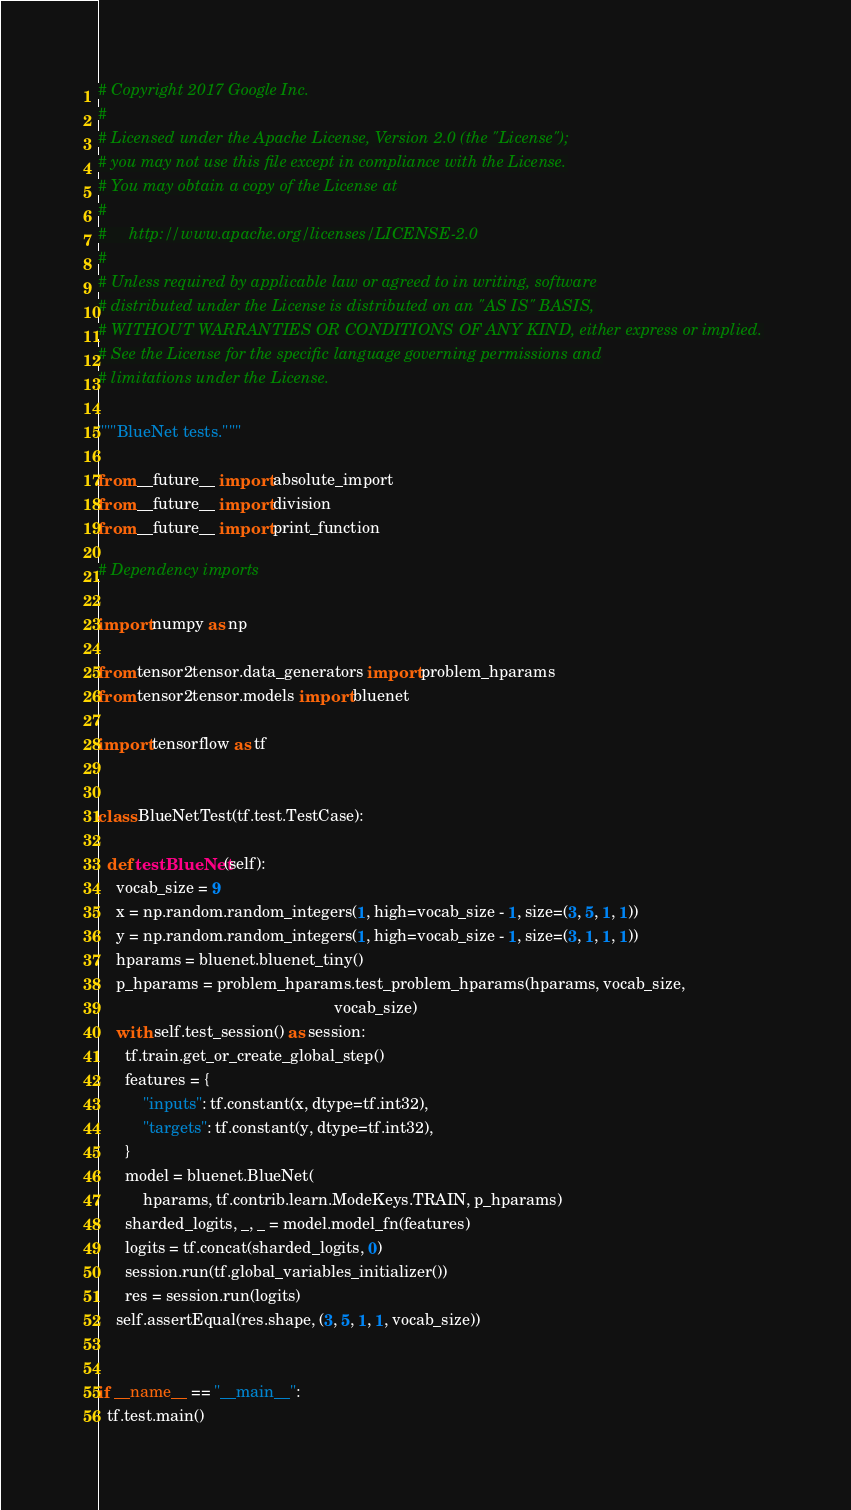Convert code to text. <code><loc_0><loc_0><loc_500><loc_500><_Python_># Copyright 2017 Google Inc.
#
# Licensed under the Apache License, Version 2.0 (the "License");
# you may not use this file except in compliance with the License.
# You may obtain a copy of the License at
#
#     http://www.apache.org/licenses/LICENSE-2.0
#
# Unless required by applicable law or agreed to in writing, software
# distributed under the License is distributed on an "AS IS" BASIS,
# WITHOUT WARRANTIES OR CONDITIONS OF ANY KIND, either express or implied.
# See the License for the specific language governing permissions and
# limitations under the License.

"""BlueNet tests."""

from __future__ import absolute_import
from __future__ import division
from __future__ import print_function

# Dependency imports

import numpy as np

from tensor2tensor.data_generators import problem_hparams
from tensor2tensor.models import bluenet

import tensorflow as tf


class BlueNetTest(tf.test.TestCase):

  def testBlueNet(self):
    vocab_size = 9
    x = np.random.random_integers(1, high=vocab_size - 1, size=(3, 5, 1, 1))
    y = np.random.random_integers(1, high=vocab_size - 1, size=(3, 1, 1, 1))
    hparams = bluenet.bluenet_tiny()
    p_hparams = problem_hparams.test_problem_hparams(hparams, vocab_size,
                                                     vocab_size)
    with self.test_session() as session:
      tf.train.get_or_create_global_step()
      features = {
          "inputs": tf.constant(x, dtype=tf.int32),
          "targets": tf.constant(y, dtype=tf.int32),
      }
      model = bluenet.BlueNet(
          hparams, tf.contrib.learn.ModeKeys.TRAIN, p_hparams)
      sharded_logits, _, _ = model.model_fn(features)
      logits = tf.concat(sharded_logits, 0)
      session.run(tf.global_variables_initializer())
      res = session.run(logits)
    self.assertEqual(res.shape, (3, 5, 1, 1, vocab_size))


if __name__ == "__main__":
  tf.test.main()
</code> 